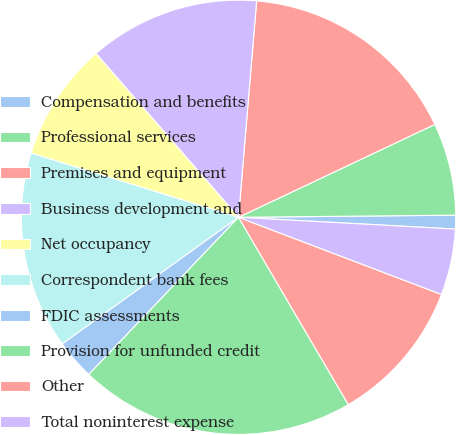Convert chart. <chart><loc_0><loc_0><loc_500><loc_500><pie_chart><fcel>Compensation and benefits<fcel>Professional services<fcel>Premises and equipment<fcel>Business development and<fcel>Net occupancy<fcel>Correspondent bank fees<fcel>FDIC assessments<fcel>Provision for unfunded credit<fcel>Other<fcel>Total noninterest expense<nl><fcel>1.02%<fcel>6.88%<fcel>16.64%<fcel>12.73%<fcel>8.83%<fcel>14.69%<fcel>2.97%<fcel>20.55%<fcel>10.78%<fcel>4.92%<nl></chart> 